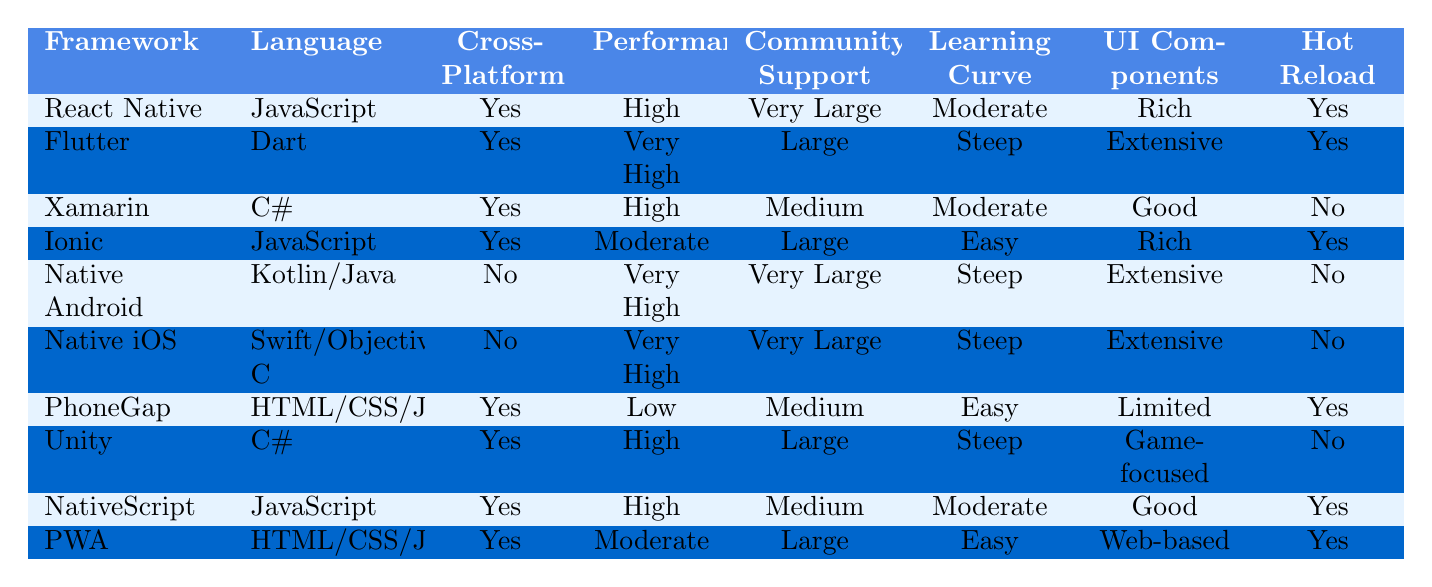What is the language used in Flutter? The table shows that Flutter is developed using the Dart programming language.
Answer: Dart Which framework has the highest performance? According to the table, both Native Android and Native iOS are marked with "Very High" for performance, indicating they share the top performance rating.
Answer: Native Android and Native iOS Is React Native a cross-platform framework? Looking at the table, React Native indicates "Yes" under the Cross-Platform column, confirming its capability as a cross-platform framework.
Answer: Yes What are the learning curves for Ionic and Xamarin? From the table, Ionic has an "Easy" learning curve, while Xamarin has a "Moderate" learning curve. The values suggest that Ionic may be easier to learn than Xamarin.
Answer: Easy and Moderate Which frameworks support hot reload? The table lists React Native, Flutter, Ionic, PhoneGap, NativeScript, and PWA as frameworks that have "Yes" under the Hot Reload column, meaning they all support hot reload.
Answer: 6 frameworks Which framework has very large community support but a steep learning curve? The table indicates that Native Android, Native iOS, and Flutter all have "Very Large" community support and a "Steep" learning curve, implying they share this characteristic.
Answer: Native Android and Native iOS What is the average performance score for cross-platform frameworks? For cross-platform frameworks, the performance scores are High (React Native, Xamarin, NativeScript), Very High (Flutter), and Moderate (Ionic and PhoneGap). To find the average, we can assign values: Low = 1, Moderate = 2, High = 3, Very High = 4. The sum of these values is (3 + 4 + 3 + 2 + 1) = 13, and there are 5 frameworks, resulting in an average of 13/5 = 2.6, which corresponds approximately to a High performance score.
Answer: High Is there any framework that does not support cross-platform development but has extensive UI components? The table indicates that both Native Android and Native iOS do not support cross-platform development and are listed with "Extensive" under UI Components.
Answer: Yes Which framework has the easiest learning curve but limited UI components? According to the table, PhoneGap has an "Easy" learning curve and "Limited" UI components, thus confirming it as the framework that meets the criteria.
Answer: PhoneGap Are there any frameworks that offer extensive UI components and support hot reload? By checking the table, we find that both Flutter and NativeScript offer "Extensive" UI components and also support hot reload, confirming they satisfy both conditions.
Answer: Yes 